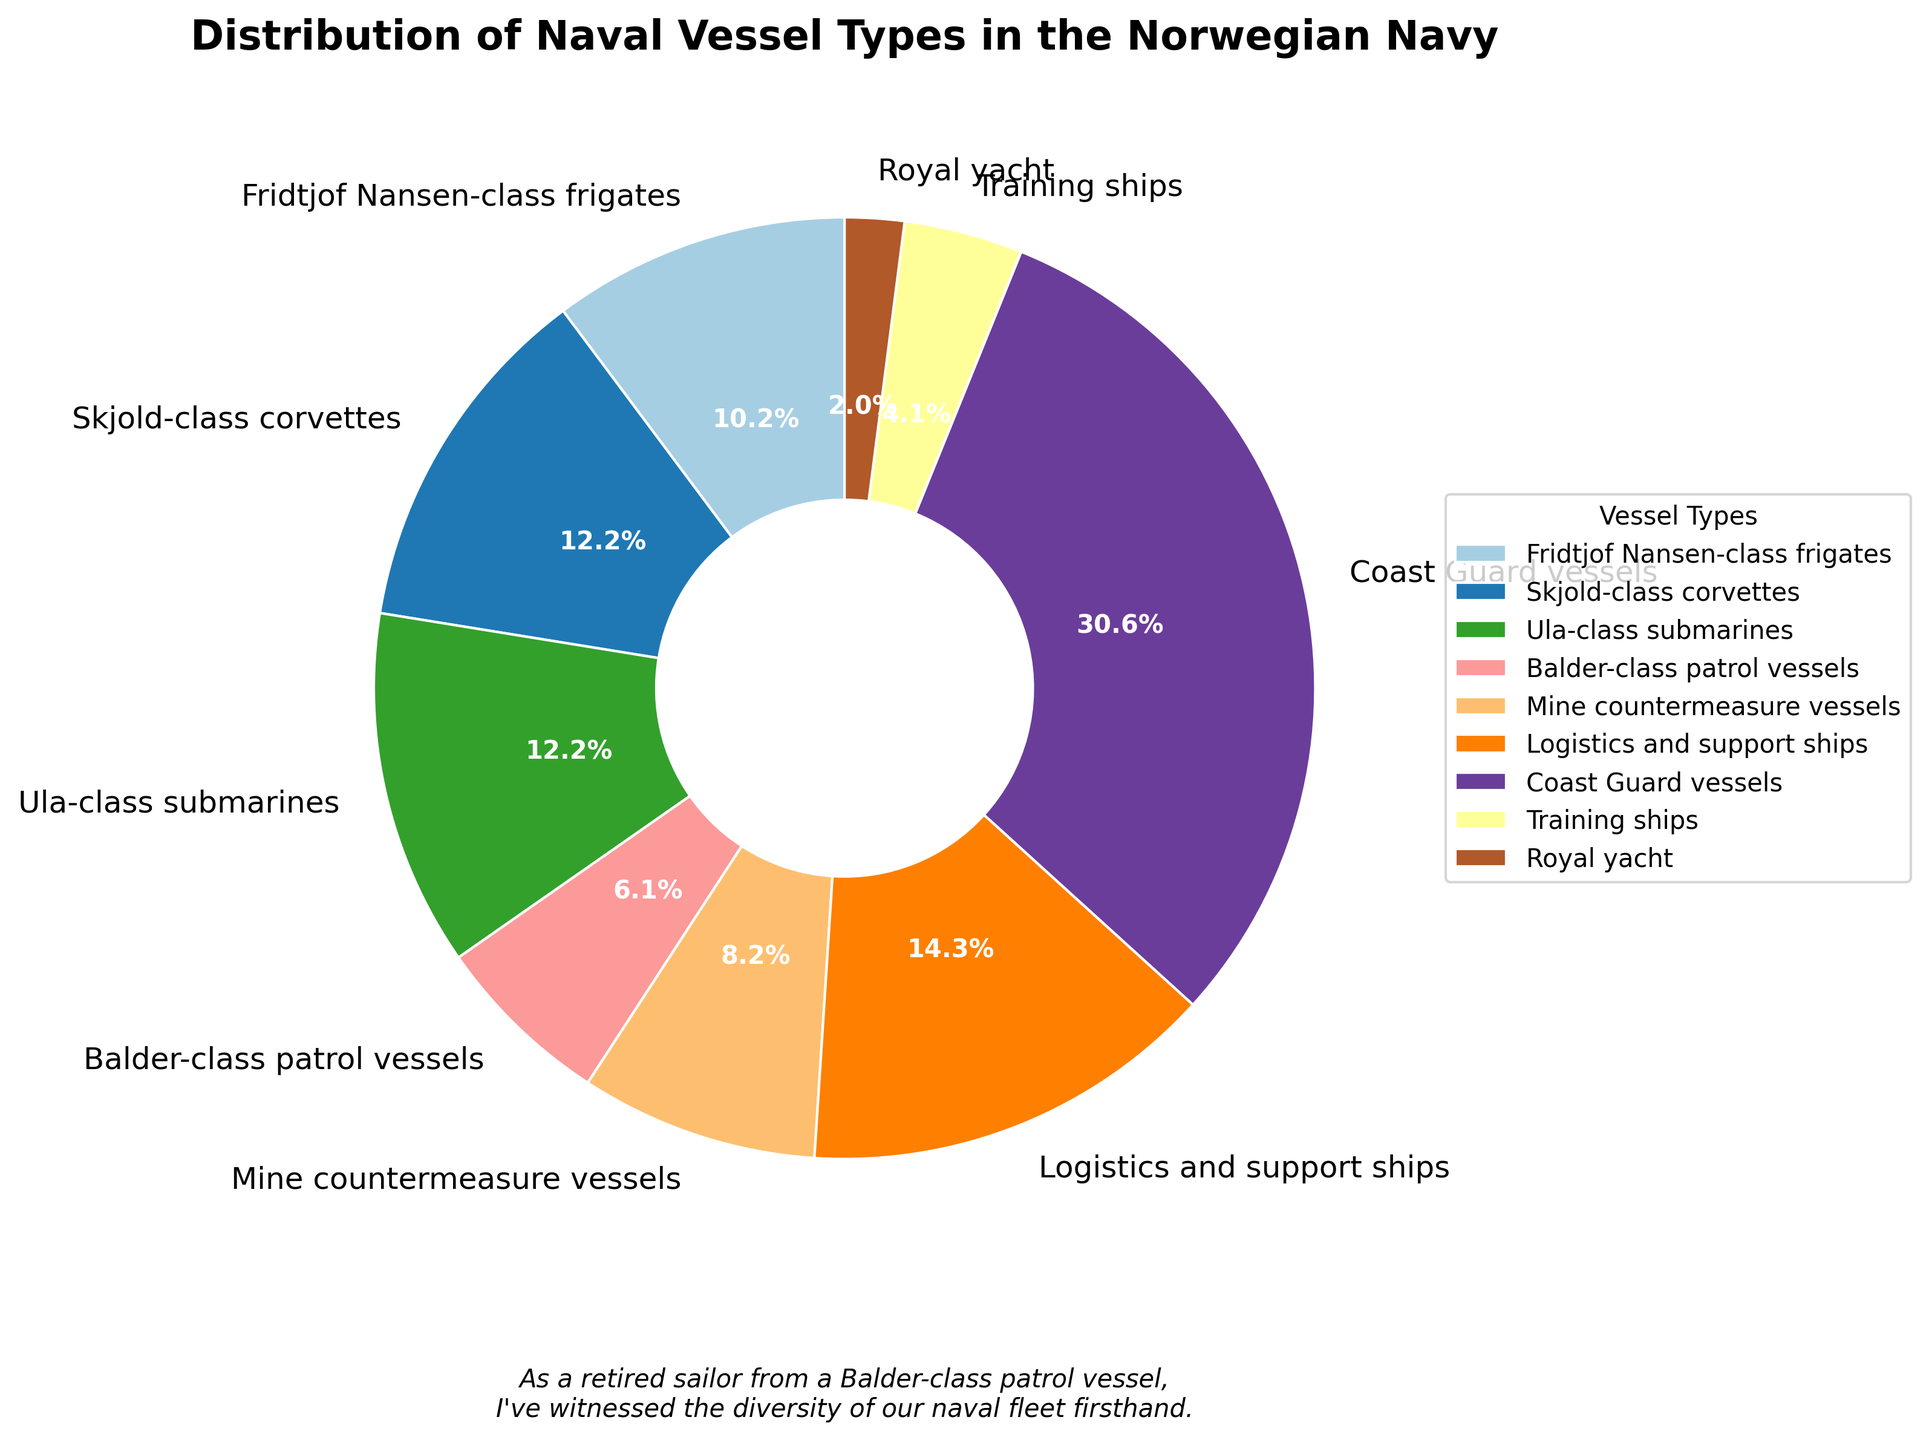How many vessel types have a percentage share greater than 10%? To determine this, we identify all the vessel types and their percentage shares. We note that Logistics and support ships (16.3%), Coast Guard vessels (34.9%), Skjold-class corvettes (14%), Ula-class submarines (14%), and Fridtjof Nansen-class frigates (11.6%) each have a percentage share greater than 10%. In total, that's 5 types.
Answer: 5 Which vessel type has the highest percentage share, and what is it? From the pie chart, we see that the Coast Guard vessels have the largest slice, constituting 34.9% of the total.
Answer: Coast Guard vessels, 34.9% What is the sum of the numbers for Logistics and support ships, Training ships, and Royal yacht? In the chart, Logistics and support ships are 7, Training ships are 2, and Royal yacht is 1. Adding them together gives us 7 + 2 + 1 = 10.
Answer: 10 Do Fridtjof Nansen-class frigates and Balder-class patrol vessels together have more vessels than the Coast Guard vessels? First, sum the numbers for Fridtjof Nansen-class frigates (5) and Balder-class patrol vessels (3). This equals 5 + 3 = 8. The Coast Guard vessels number 15, so 8 is less than 15.
Answer: No What is the difference between the number of Skjold-class corvettes and Mine countermeasure vessels? From the figure, Skjold-class corvettes number 6, and Mine countermeasure vessels number 4. The difference is 6 - 4 = 2.
Answer: 2 Which has a higher number of vessels, Ula-class submarines or Fridtjof Nansen-class frigates? By observing the chart, Ula-class submarines number 6, while Fridtjof Nansen-class frigates number 5. Therefore, Ula-class submarines have a higher number of vessels.
Answer: Ula-class submarines What percentage of the fleet do Balder-class patrol vessels represent? Balder-class patrol vessels are 3 in number out of a total of 49 vessels. Calculating the percentage: (3/49) * 100% ≈ 6.1%.
Answer: 6.1% How many more Coast Guard vessels are there compared to the combination of Training ships and Royal yacht? Coast Guard vessels number 15. Training ships and Royal yacht together are 2 (Training ships) + 1 (Royal yacht) = 3. The difference is 15 - 3 = 12.
Answer: 12 